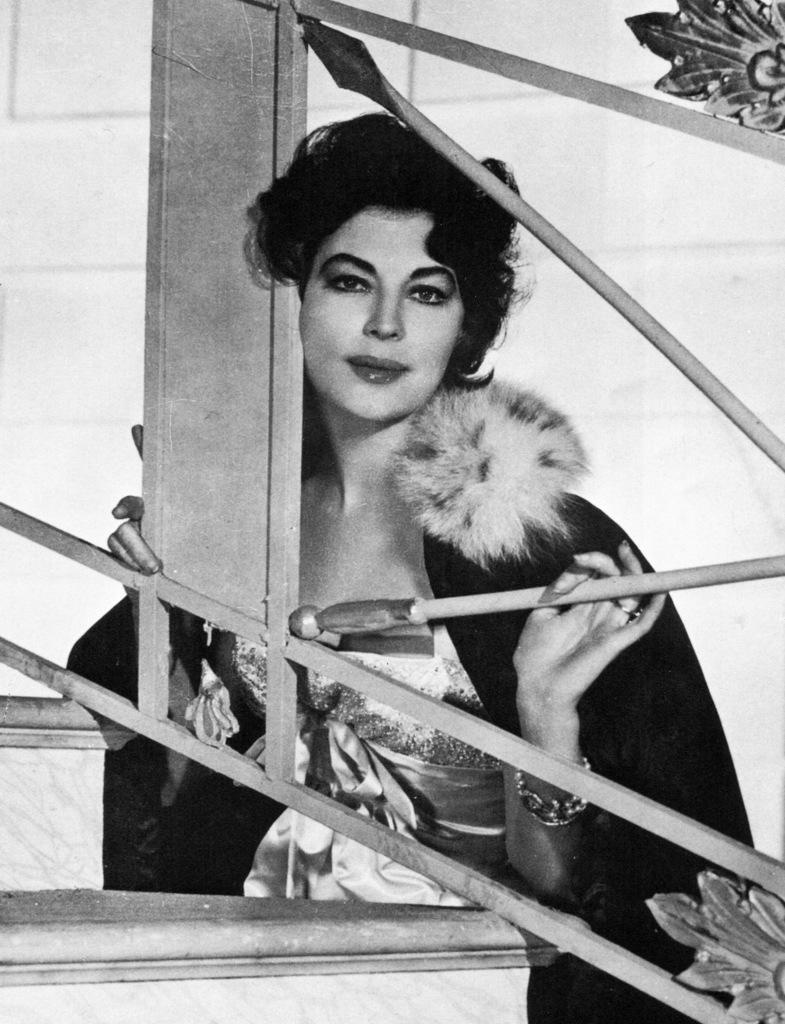Describe this image in one or two sentences. This is a black and white pic. Here we can see a woman is standing at the fence by holding a pole of it in her hand. In the background we can see the wall. 